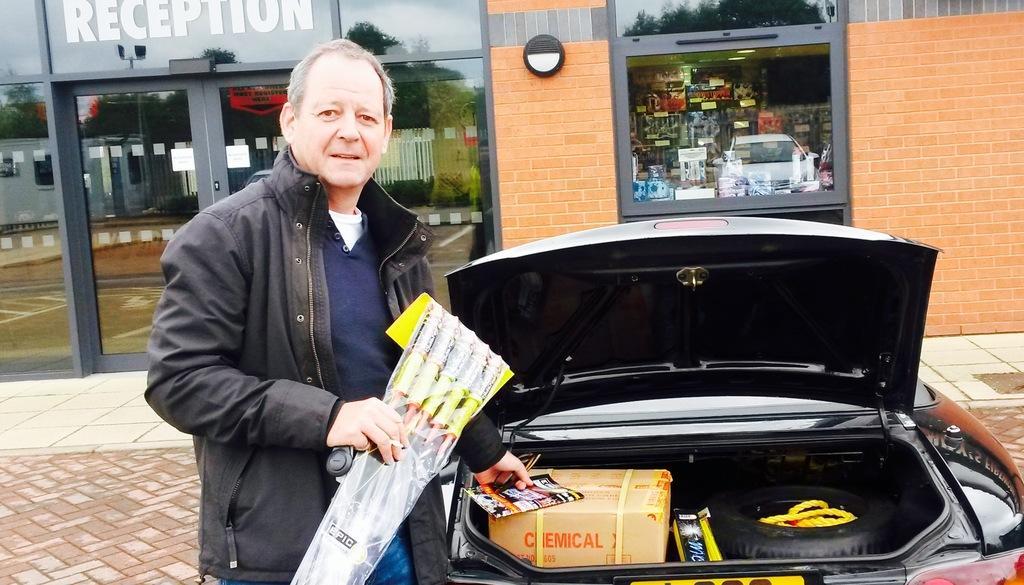In one or two sentences, can you explain what this image depicts? In this picture I can observe a person standing beside the car. The person is wearing a jacket. There is a brown color box and a tyre in the car. In the background I can observe a building. 